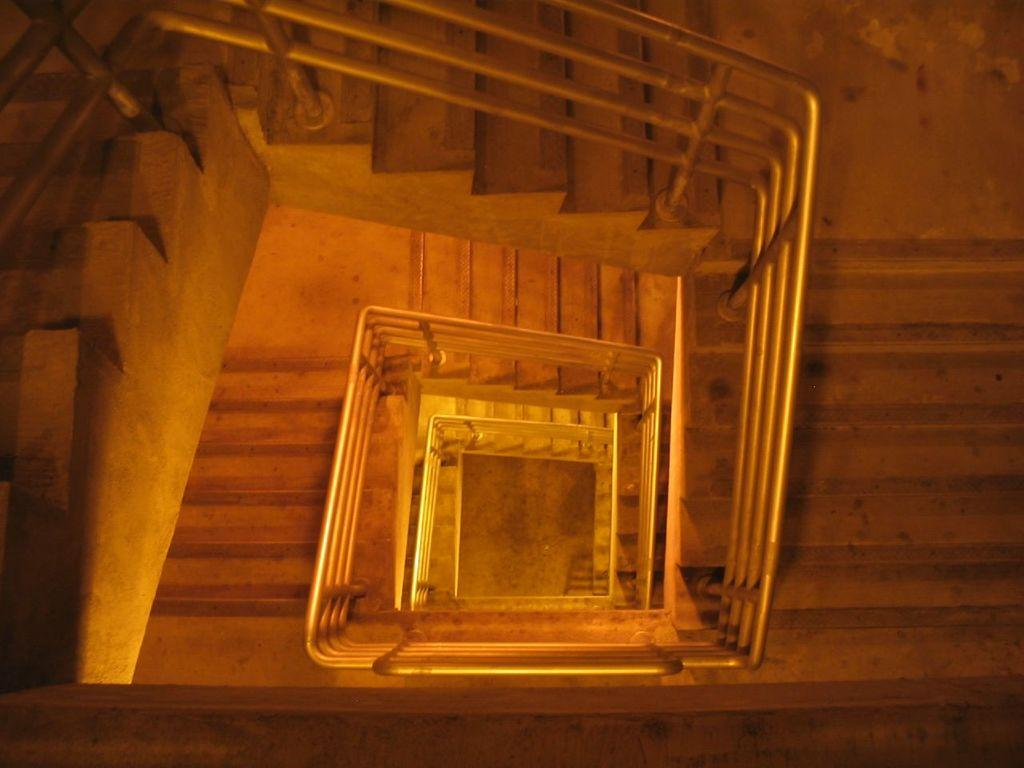What type of structure is present in the image? There are stairs in the image. What feature is present along the stairs? The stairs have a railing. What type of string is tied to the railing in the image? There is no string tied to the railing in the image. Is there a baseball game happening in the background of the image? There is no baseball game or any reference to sports in the image; it only features stairs with a railing. 